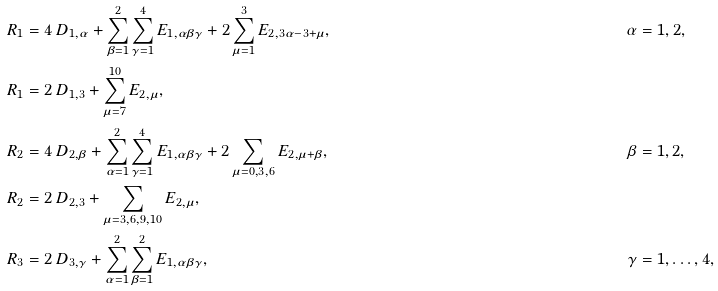Convert formula to latex. <formula><loc_0><loc_0><loc_500><loc_500>R _ { 1 } & = 4 \, D _ { 1 , \alpha } + \sum _ { \beta = 1 } ^ { 2 } \sum _ { \gamma = 1 } ^ { 4 } E _ { 1 , { \alpha \beta \gamma } } + 2 \sum _ { \mu = 1 } ^ { 3 } E _ { 2 , 3 \alpha - 3 + \mu } , & & \alpha = 1 , 2 , \\ R _ { 1 } & = 2 \, D _ { 1 , 3 } + \sum _ { \mu = 7 } ^ { 1 0 } E _ { 2 , \mu } , \\ R _ { 2 } & = 4 \, D _ { 2 , \beta } + \sum _ { \alpha = 1 } ^ { 2 } \sum _ { \gamma = 1 } ^ { 4 } E _ { 1 , { \alpha \beta \gamma } } + 2 \sum _ { \mu = 0 , 3 , 6 } E _ { 2 , \mu + \beta } , & & \beta = 1 , 2 , \\ R _ { 2 } & = 2 \, D _ { 2 , 3 } + \sum _ { \mu = 3 , 6 , 9 , 1 0 } E _ { 2 , \mu } , \\ R _ { 3 } & = 2 \, D _ { 3 , \gamma } + \sum _ { \alpha = 1 } ^ { 2 } \sum _ { \beta = 1 } ^ { 2 } E _ { 1 , { \alpha \beta \gamma } } , & & \gamma = 1 , \dots , 4 ,</formula> 